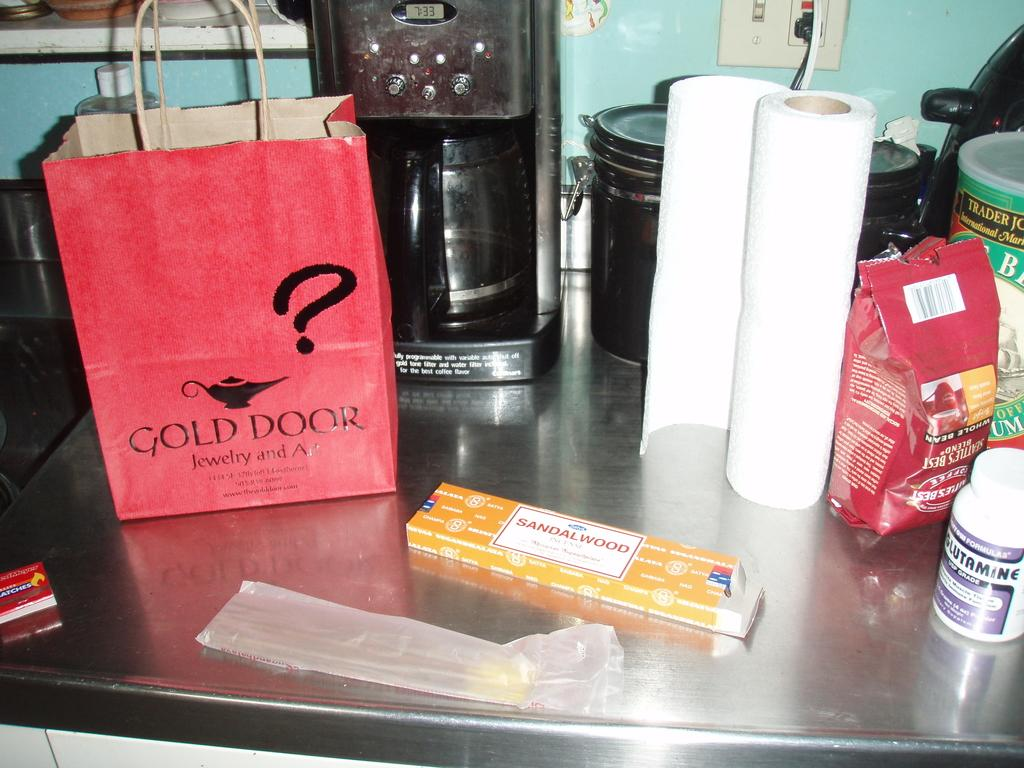<image>
Summarize the visual content of the image. Bag, Paper Towels, and different other items; which the bag says Gold Door Jewelry and Art. 